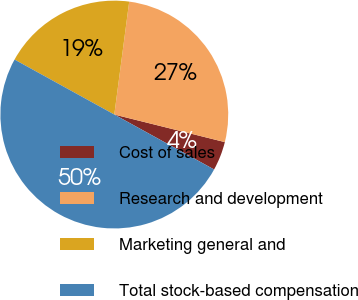<chart> <loc_0><loc_0><loc_500><loc_500><pie_chart><fcel>Cost of sales<fcel>Research and development<fcel>Marketing general and<fcel>Total stock-based compensation<nl><fcel>4.12%<fcel>26.8%<fcel>19.07%<fcel>50.0%<nl></chart> 